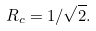<formula> <loc_0><loc_0><loc_500><loc_500>R _ { c } = 1 / \sqrt { 2 } .</formula> 